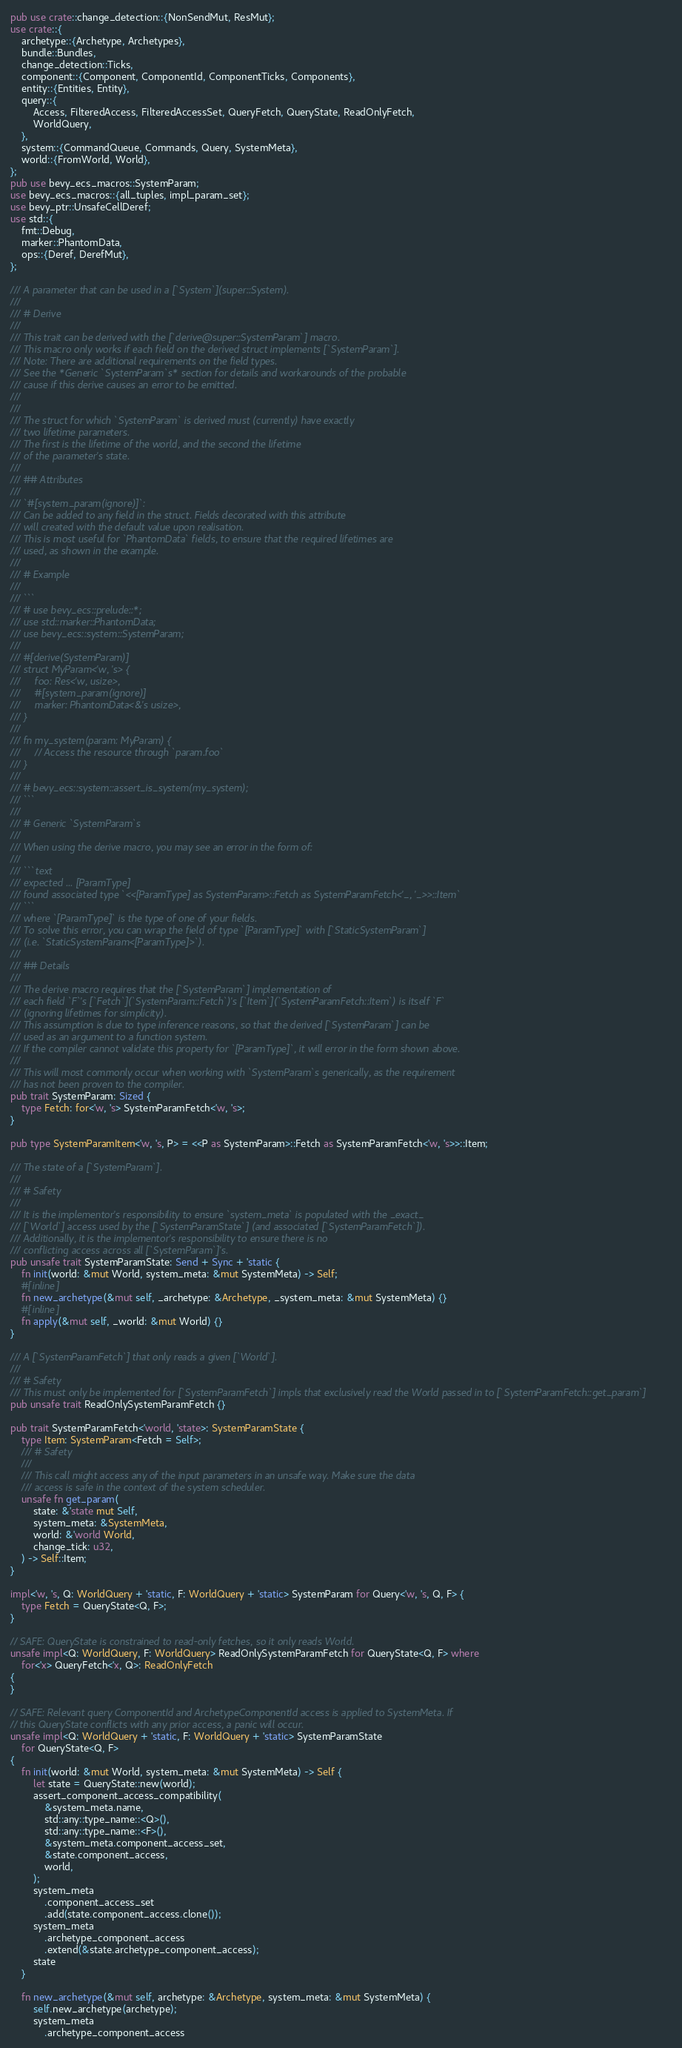<code> <loc_0><loc_0><loc_500><loc_500><_Rust_>pub use crate::change_detection::{NonSendMut, ResMut};
use crate::{
    archetype::{Archetype, Archetypes},
    bundle::Bundles,
    change_detection::Ticks,
    component::{Component, ComponentId, ComponentTicks, Components},
    entity::{Entities, Entity},
    query::{
        Access, FilteredAccess, FilteredAccessSet, QueryFetch, QueryState, ReadOnlyFetch,
        WorldQuery,
    },
    system::{CommandQueue, Commands, Query, SystemMeta},
    world::{FromWorld, World},
};
pub use bevy_ecs_macros::SystemParam;
use bevy_ecs_macros::{all_tuples, impl_param_set};
use bevy_ptr::UnsafeCellDeref;
use std::{
    fmt::Debug,
    marker::PhantomData,
    ops::{Deref, DerefMut},
};

/// A parameter that can be used in a [`System`](super::System).
///
/// # Derive
///
/// This trait can be derived with the [`derive@super::SystemParam`] macro.
/// This macro only works if each field on the derived struct implements [`SystemParam`].
/// Note: There are additional requirements on the field types.
/// See the *Generic `SystemParam`s* section for details and workarounds of the probable
/// cause if this derive causes an error to be emitted.
///
///
/// The struct for which `SystemParam` is derived must (currently) have exactly
/// two lifetime parameters.
/// The first is the lifetime of the world, and the second the lifetime
/// of the parameter's state.
///
/// ## Attributes
///
/// `#[system_param(ignore)]`:
/// Can be added to any field in the struct. Fields decorated with this attribute
/// will created with the default value upon realisation.
/// This is most useful for `PhantomData` fields, to ensure that the required lifetimes are
/// used, as shown in the example.
///
/// # Example
///
/// ```
/// # use bevy_ecs::prelude::*;
/// use std::marker::PhantomData;
/// use bevy_ecs::system::SystemParam;
///
/// #[derive(SystemParam)]
/// struct MyParam<'w, 's> {
///     foo: Res<'w, usize>,
///     #[system_param(ignore)]
///     marker: PhantomData<&'s usize>,
/// }
///
/// fn my_system(param: MyParam) {
///     // Access the resource through `param.foo`
/// }
///
/// # bevy_ecs::system::assert_is_system(my_system);
/// ```
///
/// # Generic `SystemParam`s
///
/// When using the derive macro, you may see an error in the form of:
///
/// ```text
/// expected ... [ParamType]
/// found associated type `<<[ParamType] as SystemParam>::Fetch as SystemParamFetch<'_, '_>>::Item`
/// ```
/// where `[ParamType]` is the type of one of your fields.
/// To solve this error, you can wrap the field of type `[ParamType]` with [`StaticSystemParam`]
/// (i.e. `StaticSystemParam<[ParamType]>`).
///
/// ## Details
///
/// The derive macro requires that the [`SystemParam`] implementation of
/// each field `F`'s [`Fetch`](`SystemParam::Fetch`)'s [`Item`](`SystemParamFetch::Item`) is itself `F`
/// (ignoring lifetimes for simplicity).
/// This assumption is due to type inference reasons, so that the derived [`SystemParam`] can be
/// used as an argument to a function system.
/// If the compiler cannot validate this property for `[ParamType]`, it will error in the form shown above.
///
/// This will most commonly occur when working with `SystemParam`s generically, as the requirement
/// has not been proven to the compiler.
pub trait SystemParam: Sized {
    type Fetch: for<'w, 's> SystemParamFetch<'w, 's>;
}

pub type SystemParamItem<'w, 's, P> = <<P as SystemParam>::Fetch as SystemParamFetch<'w, 's>>::Item;

/// The state of a [`SystemParam`].
///
/// # Safety
///
/// It is the implementor's responsibility to ensure `system_meta` is populated with the _exact_
/// [`World`] access used by the [`SystemParamState`] (and associated [`SystemParamFetch`]).
/// Additionally, it is the implementor's responsibility to ensure there is no
/// conflicting access across all [`SystemParam`]'s.
pub unsafe trait SystemParamState: Send + Sync + 'static {
    fn init(world: &mut World, system_meta: &mut SystemMeta) -> Self;
    #[inline]
    fn new_archetype(&mut self, _archetype: &Archetype, _system_meta: &mut SystemMeta) {}
    #[inline]
    fn apply(&mut self, _world: &mut World) {}
}

/// A [`SystemParamFetch`] that only reads a given [`World`].
///
/// # Safety
/// This must only be implemented for [`SystemParamFetch`] impls that exclusively read the World passed in to [`SystemParamFetch::get_param`]
pub unsafe trait ReadOnlySystemParamFetch {}

pub trait SystemParamFetch<'world, 'state>: SystemParamState {
    type Item: SystemParam<Fetch = Self>;
    /// # Safety
    ///
    /// This call might access any of the input parameters in an unsafe way. Make sure the data
    /// access is safe in the context of the system scheduler.
    unsafe fn get_param(
        state: &'state mut Self,
        system_meta: &SystemMeta,
        world: &'world World,
        change_tick: u32,
    ) -> Self::Item;
}

impl<'w, 's, Q: WorldQuery + 'static, F: WorldQuery + 'static> SystemParam for Query<'w, 's, Q, F> {
    type Fetch = QueryState<Q, F>;
}

// SAFE: QueryState is constrained to read-only fetches, so it only reads World.
unsafe impl<Q: WorldQuery, F: WorldQuery> ReadOnlySystemParamFetch for QueryState<Q, F> where
    for<'x> QueryFetch<'x, Q>: ReadOnlyFetch
{
}

// SAFE: Relevant query ComponentId and ArchetypeComponentId access is applied to SystemMeta. If
// this QueryState conflicts with any prior access, a panic will occur.
unsafe impl<Q: WorldQuery + 'static, F: WorldQuery + 'static> SystemParamState
    for QueryState<Q, F>
{
    fn init(world: &mut World, system_meta: &mut SystemMeta) -> Self {
        let state = QueryState::new(world);
        assert_component_access_compatibility(
            &system_meta.name,
            std::any::type_name::<Q>(),
            std::any::type_name::<F>(),
            &system_meta.component_access_set,
            &state.component_access,
            world,
        );
        system_meta
            .component_access_set
            .add(state.component_access.clone());
        system_meta
            .archetype_component_access
            .extend(&state.archetype_component_access);
        state
    }

    fn new_archetype(&mut self, archetype: &Archetype, system_meta: &mut SystemMeta) {
        self.new_archetype(archetype);
        system_meta
            .archetype_component_access</code> 